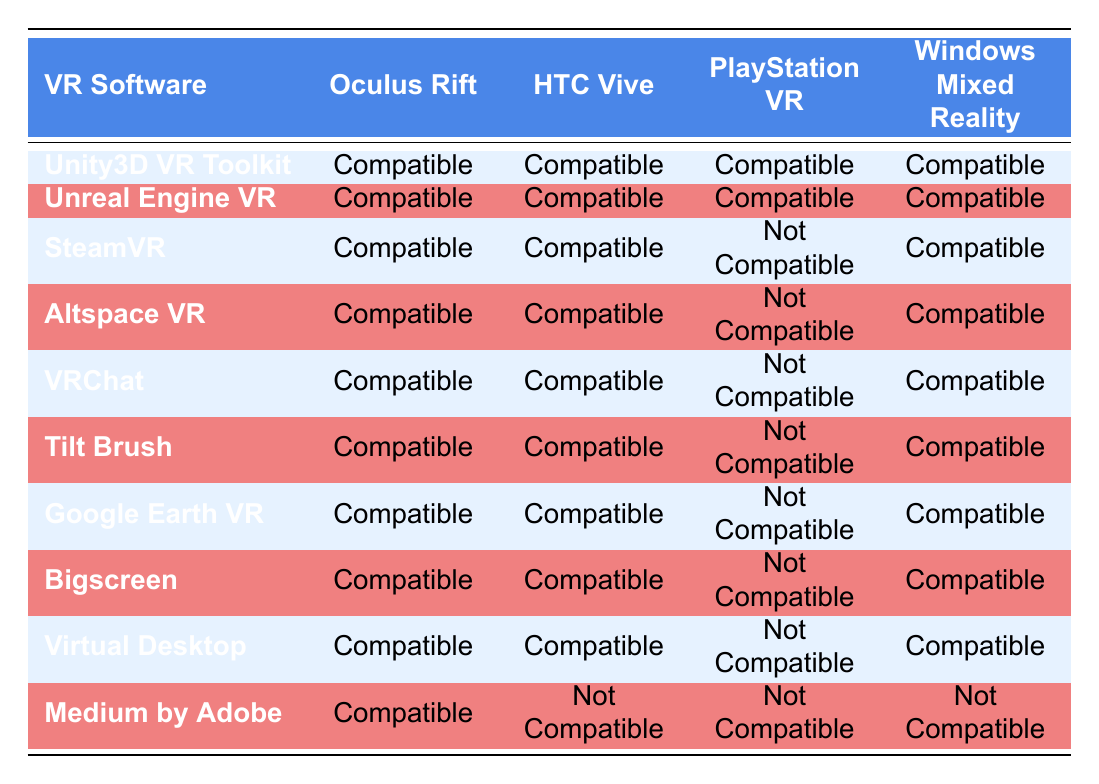What VR software is compatible with PlayStation VR? By looking through the "PlayStation VR" column, we identify which software entries list "Compatible." The compatible software are Unity3D VR Toolkit, Unreal Engine VR, SteamVR, Altspace VR, VRChat, Tilt Brush, Google Earth VR, Bigscreen, and Virtual Desktop.
Answer: Unity3D VR Toolkit, Unreal Engine VR, SteamVR, Altspace VR, VRChat, Tilt Brush, Google Earth VR, Bigscreen, Virtual Desktop Is Medium by Adobe compatible with HTC Vive? We check the "HTC Vive" column for the entry corresponding to Medium by Adobe. There, it lists "Not Compatible." Thus, the answer is no.
Answer: No Which VR software is not compatible with any hardware? We search for software entries that list "Not Compatible" across all hardware categories. As we check all rows, we find that Medium by Adobe is the only software listed as "Not Compatible" with Oculus Rift, HTC Vive, PlayStation VR, and Windows Mixed Reality.
Answer: Medium by Adobe How many VR software options are compatible with Windows Mixed Reality? We examine the "Windows Mixed Reality" column and count the number of entries that list "Compatible." The compatible software are Unity3D VR Toolkit, Unreal Engine VR, SteamVR, Altspace VR, VRChat, Tilt Brush, Google Earth VR, Bigscreen, and Virtual Desktop, totaling 9 software options.
Answer: 9 Which VR headset has the least compatibility with software? To find the headset with the least compatibility, we tally the number of "Not Compatible" entries for each headset. Oculus Rift has 1, HTC Vive has 2, PlayStation VR has 8, and Windows Mixed Reality has 1. The PlayStation VR has the maximum number of "Not Compatible" entries, which indicates it has the least compatibility overall.
Answer: PlayStation VR 